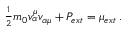<formula> <loc_0><loc_0><loc_500><loc_500>\begin{array} { r } { { \frac { 1 } { 2 } } m _ { 0 } v _ { \alpha } ^ { \mu } v _ { \alpha \mu } + P _ { e x t } = \mu _ { e x t } \, . } \end{array}</formula> 